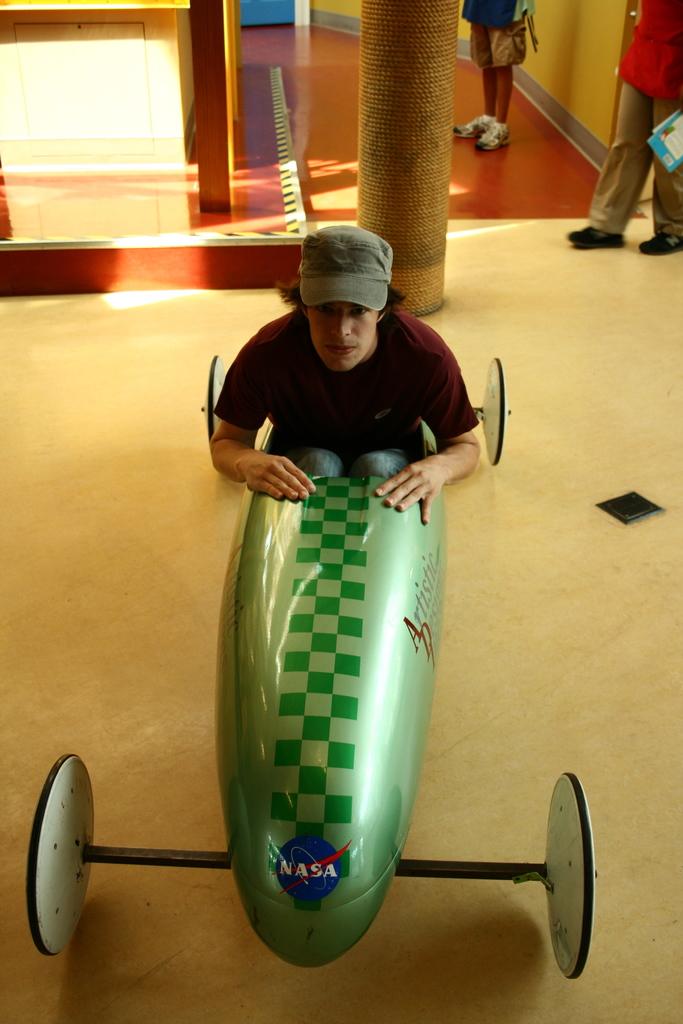Was this made by nasa?
Offer a terse response. Yes. Which government agency is featured?
Make the answer very short. Nasa. 